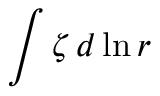<formula> <loc_0><loc_0><loc_500><loc_500>\int \zeta \, d \ln r</formula> 